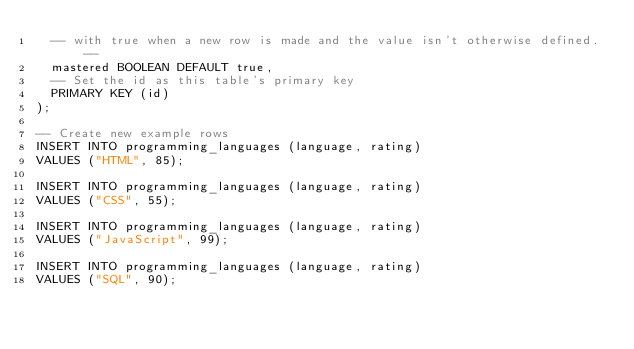Convert code to text. <code><loc_0><loc_0><loc_500><loc_500><_SQL_>  -- with true when a new row is made and the value isn't otherwise defined. --
  mastered BOOLEAN DEFAULT true,
  -- Set the id as this table's primary key
  PRIMARY KEY (id)
);

-- Create new example rows
INSERT INTO programming_languages (language, rating)
VALUES ("HTML", 85);

INSERT INTO programming_languages (language, rating)
VALUES ("CSS", 55);

INSERT INTO programming_languages (language, rating)
VALUES ("JavaScript", 99);

INSERT INTO programming_languages (language, rating)
VALUES ("SQL", 90);
</code> 